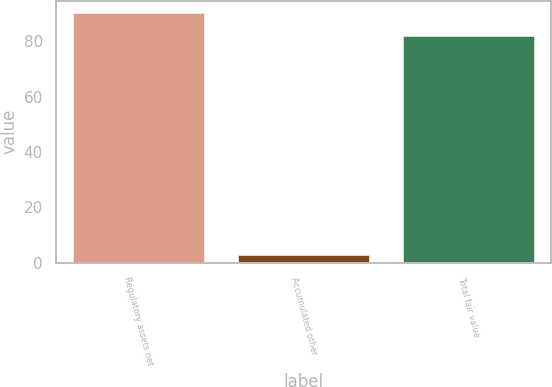Convert chart. <chart><loc_0><loc_0><loc_500><loc_500><bar_chart><fcel>Regulatory assets net<fcel>Accumulated other<fcel>Total fair value<nl><fcel>90.2<fcel>3<fcel>82<nl></chart> 